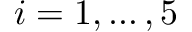<formula> <loc_0><loc_0><loc_500><loc_500>i = 1 , \dots , 5</formula> 